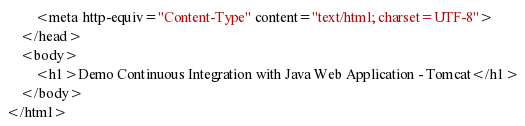<code> <loc_0><loc_0><loc_500><loc_500><_HTML_>        <meta http-equiv="Content-Type" content="text/html; charset=UTF-8">
    </head>
    <body>
        <h1>Demo Continuous Integration with Java Web Application - Tomcat</h1>
    </body>
</html>
</code> 